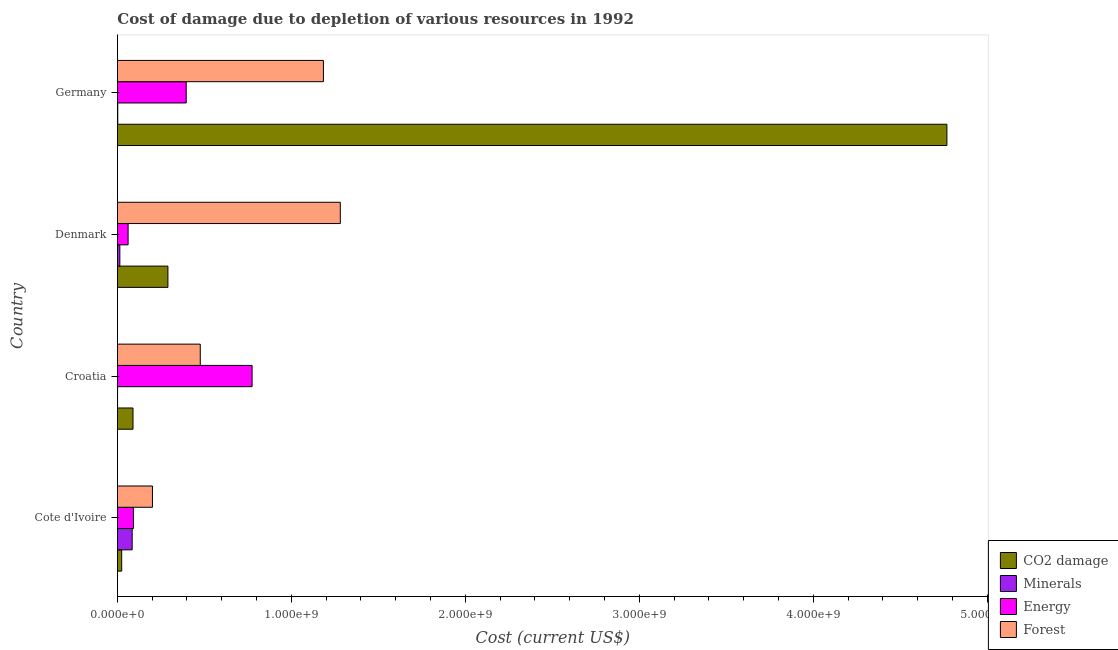How many different coloured bars are there?
Your answer should be compact. 4. How many bars are there on the 3rd tick from the top?
Your answer should be compact. 4. What is the label of the 1st group of bars from the top?
Make the answer very short. Germany. In how many cases, is the number of bars for a given country not equal to the number of legend labels?
Provide a succinct answer. 0. What is the cost of damage due to depletion of energy in Denmark?
Your answer should be compact. 6.16e+07. Across all countries, what is the maximum cost of damage due to depletion of coal?
Ensure brevity in your answer.  4.77e+09. Across all countries, what is the minimum cost of damage due to depletion of minerals?
Your answer should be very brief. 9.29e+05. In which country was the cost of damage due to depletion of minerals maximum?
Provide a succinct answer. Cote d'Ivoire. In which country was the cost of damage due to depletion of minerals minimum?
Your response must be concise. Croatia. What is the total cost of damage due to depletion of minerals in the graph?
Give a very brief answer. 1.02e+08. What is the difference between the cost of damage due to depletion of forests in Cote d'Ivoire and that in Germany?
Offer a very short reply. -9.83e+08. What is the difference between the cost of damage due to depletion of energy in Croatia and the cost of damage due to depletion of minerals in Germany?
Keep it short and to the point. 7.72e+08. What is the average cost of damage due to depletion of minerals per country?
Give a very brief answer. 2.55e+07. What is the difference between the cost of damage due to depletion of minerals and cost of damage due to depletion of energy in Croatia?
Your answer should be compact. -7.73e+08. In how many countries, is the cost of damage due to depletion of coal greater than 2600000000 US$?
Offer a terse response. 1. What is the ratio of the cost of damage due to depletion of coal in Cote d'Ivoire to that in Croatia?
Offer a very short reply. 0.28. Is the cost of damage due to depletion of coal in Croatia less than that in Germany?
Your response must be concise. Yes. What is the difference between the highest and the second highest cost of damage due to depletion of energy?
Provide a succinct answer. 3.79e+08. What is the difference between the highest and the lowest cost of damage due to depletion of energy?
Make the answer very short. 7.13e+08. In how many countries, is the cost of damage due to depletion of forests greater than the average cost of damage due to depletion of forests taken over all countries?
Provide a succinct answer. 2. Is the sum of the cost of damage due to depletion of energy in Denmark and Germany greater than the maximum cost of damage due to depletion of forests across all countries?
Your answer should be very brief. No. What does the 2nd bar from the top in Croatia represents?
Your response must be concise. Energy. What does the 4th bar from the bottom in Denmark represents?
Provide a succinct answer. Forest. Is it the case that in every country, the sum of the cost of damage due to depletion of coal and cost of damage due to depletion of minerals is greater than the cost of damage due to depletion of energy?
Keep it short and to the point. No. Are all the bars in the graph horizontal?
Keep it short and to the point. Yes. What is the difference between two consecutive major ticks on the X-axis?
Offer a terse response. 1.00e+09. Are the values on the major ticks of X-axis written in scientific E-notation?
Offer a very short reply. Yes. Does the graph contain any zero values?
Provide a short and direct response. No. Does the graph contain grids?
Offer a very short reply. No. How many legend labels are there?
Make the answer very short. 4. What is the title of the graph?
Your answer should be very brief. Cost of damage due to depletion of various resources in 1992 . What is the label or title of the X-axis?
Provide a short and direct response. Cost (current US$). What is the label or title of the Y-axis?
Provide a short and direct response. Country. What is the Cost (current US$) in CO2 damage in Cote d'Ivoire?
Make the answer very short. 2.47e+07. What is the Cost (current US$) of Minerals in Cote d'Ivoire?
Provide a succinct answer. 8.49e+07. What is the Cost (current US$) in Energy in Cote d'Ivoire?
Your answer should be very brief. 9.22e+07. What is the Cost (current US$) in Forest in Cote d'Ivoire?
Your answer should be very brief. 2.01e+08. What is the Cost (current US$) in CO2 damage in Croatia?
Provide a succinct answer. 8.97e+07. What is the Cost (current US$) in Minerals in Croatia?
Offer a very short reply. 9.29e+05. What is the Cost (current US$) of Energy in Croatia?
Provide a succinct answer. 7.74e+08. What is the Cost (current US$) of Forest in Croatia?
Your answer should be very brief. 4.76e+08. What is the Cost (current US$) of CO2 damage in Denmark?
Ensure brevity in your answer.  2.90e+08. What is the Cost (current US$) in Minerals in Denmark?
Ensure brevity in your answer.  1.40e+07. What is the Cost (current US$) of Energy in Denmark?
Keep it short and to the point. 6.16e+07. What is the Cost (current US$) of Forest in Denmark?
Give a very brief answer. 1.28e+09. What is the Cost (current US$) in CO2 damage in Germany?
Your answer should be compact. 4.77e+09. What is the Cost (current US$) of Minerals in Germany?
Your answer should be very brief. 2.06e+06. What is the Cost (current US$) in Energy in Germany?
Your response must be concise. 3.95e+08. What is the Cost (current US$) of Forest in Germany?
Provide a succinct answer. 1.18e+09. Across all countries, what is the maximum Cost (current US$) of CO2 damage?
Provide a short and direct response. 4.77e+09. Across all countries, what is the maximum Cost (current US$) of Minerals?
Offer a terse response. 8.49e+07. Across all countries, what is the maximum Cost (current US$) of Energy?
Keep it short and to the point. 7.74e+08. Across all countries, what is the maximum Cost (current US$) of Forest?
Make the answer very short. 1.28e+09. Across all countries, what is the minimum Cost (current US$) of CO2 damage?
Your answer should be very brief. 2.47e+07. Across all countries, what is the minimum Cost (current US$) in Minerals?
Your answer should be compact. 9.29e+05. Across all countries, what is the minimum Cost (current US$) in Energy?
Keep it short and to the point. 6.16e+07. Across all countries, what is the minimum Cost (current US$) in Forest?
Your answer should be compact. 2.01e+08. What is the total Cost (current US$) of CO2 damage in the graph?
Provide a succinct answer. 5.17e+09. What is the total Cost (current US$) in Minerals in the graph?
Give a very brief answer. 1.02e+08. What is the total Cost (current US$) of Energy in the graph?
Keep it short and to the point. 1.32e+09. What is the total Cost (current US$) in Forest in the graph?
Provide a succinct answer. 3.14e+09. What is the difference between the Cost (current US$) in CO2 damage in Cote d'Ivoire and that in Croatia?
Give a very brief answer. -6.49e+07. What is the difference between the Cost (current US$) in Minerals in Cote d'Ivoire and that in Croatia?
Make the answer very short. 8.40e+07. What is the difference between the Cost (current US$) of Energy in Cote d'Ivoire and that in Croatia?
Make the answer very short. -6.82e+08. What is the difference between the Cost (current US$) of Forest in Cote d'Ivoire and that in Croatia?
Keep it short and to the point. -2.75e+08. What is the difference between the Cost (current US$) of CO2 damage in Cote d'Ivoire and that in Denmark?
Ensure brevity in your answer.  -2.66e+08. What is the difference between the Cost (current US$) of Minerals in Cote d'Ivoire and that in Denmark?
Offer a terse response. 7.09e+07. What is the difference between the Cost (current US$) in Energy in Cote d'Ivoire and that in Denmark?
Give a very brief answer. 3.06e+07. What is the difference between the Cost (current US$) of Forest in Cote d'Ivoire and that in Denmark?
Ensure brevity in your answer.  -1.08e+09. What is the difference between the Cost (current US$) in CO2 damage in Cote d'Ivoire and that in Germany?
Your response must be concise. -4.74e+09. What is the difference between the Cost (current US$) of Minerals in Cote d'Ivoire and that in Germany?
Your answer should be compact. 8.28e+07. What is the difference between the Cost (current US$) in Energy in Cote d'Ivoire and that in Germany?
Ensure brevity in your answer.  -3.03e+08. What is the difference between the Cost (current US$) in Forest in Cote d'Ivoire and that in Germany?
Provide a short and direct response. -9.83e+08. What is the difference between the Cost (current US$) in CO2 damage in Croatia and that in Denmark?
Your answer should be very brief. -2.01e+08. What is the difference between the Cost (current US$) in Minerals in Croatia and that in Denmark?
Offer a terse response. -1.31e+07. What is the difference between the Cost (current US$) in Energy in Croatia and that in Denmark?
Give a very brief answer. 7.13e+08. What is the difference between the Cost (current US$) of Forest in Croatia and that in Denmark?
Provide a short and direct response. -8.05e+08. What is the difference between the Cost (current US$) of CO2 damage in Croatia and that in Germany?
Keep it short and to the point. -4.68e+09. What is the difference between the Cost (current US$) in Minerals in Croatia and that in Germany?
Offer a very short reply. -1.14e+06. What is the difference between the Cost (current US$) in Energy in Croatia and that in Germany?
Ensure brevity in your answer.  3.79e+08. What is the difference between the Cost (current US$) of Forest in Croatia and that in Germany?
Ensure brevity in your answer.  -7.08e+08. What is the difference between the Cost (current US$) of CO2 damage in Denmark and that in Germany?
Make the answer very short. -4.48e+09. What is the difference between the Cost (current US$) in Minerals in Denmark and that in Germany?
Provide a succinct answer. 1.20e+07. What is the difference between the Cost (current US$) of Energy in Denmark and that in Germany?
Offer a terse response. -3.34e+08. What is the difference between the Cost (current US$) of Forest in Denmark and that in Germany?
Provide a short and direct response. 9.71e+07. What is the difference between the Cost (current US$) of CO2 damage in Cote d'Ivoire and the Cost (current US$) of Minerals in Croatia?
Offer a very short reply. 2.38e+07. What is the difference between the Cost (current US$) in CO2 damage in Cote d'Ivoire and the Cost (current US$) in Energy in Croatia?
Offer a very short reply. -7.50e+08. What is the difference between the Cost (current US$) in CO2 damage in Cote d'Ivoire and the Cost (current US$) in Forest in Croatia?
Provide a succinct answer. -4.52e+08. What is the difference between the Cost (current US$) in Minerals in Cote d'Ivoire and the Cost (current US$) in Energy in Croatia?
Keep it short and to the point. -6.89e+08. What is the difference between the Cost (current US$) of Minerals in Cote d'Ivoire and the Cost (current US$) of Forest in Croatia?
Offer a very short reply. -3.91e+08. What is the difference between the Cost (current US$) in Energy in Cote d'Ivoire and the Cost (current US$) in Forest in Croatia?
Provide a succinct answer. -3.84e+08. What is the difference between the Cost (current US$) of CO2 damage in Cote d'Ivoire and the Cost (current US$) of Minerals in Denmark?
Keep it short and to the point. 1.07e+07. What is the difference between the Cost (current US$) in CO2 damage in Cote d'Ivoire and the Cost (current US$) in Energy in Denmark?
Provide a short and direct response. -3.69e+07. What is the difference between the Cost (current US$) of CO2 damage in Cote d'Ivoire and the Cost (current US$) of Forest in Denmark?
Your answer should be compact. -1.26e+09. What is the difference between the Cost (current US$) in Minerals in Cote d'Ivoire and the Cost (current US$) in Energy in Denmark?
Ensure brevity in your answer.  2.33e+07. What is the difference between the Cost (current US$) of Minerals in Cote d'Ivoire and the Cost (current US$) of Forest in Denmark?
Your response must be concise. -1.20e+09. What is the difference between the Cost (current US$) of Energy in Cote d'Ivoire and the Cost (current US$) of Forest in Denmark?
Provide a succinct answer. -1.19e+09. What is the difference between the Cost (current US$) in CO2 damage in Cote d'Ivoire and the Cost (current US$) in Minerals in Germany?
Offer a very short reply. 2.27e+07. What is the difference between the Cost (current US$) of CO2 damage in Cote d'Ivoire and the Cost (current US$) of Energy in Germany?
Offer a terse response. -3.71e+08. What is the difference between the Cost (current US$) in CO2 damage in Cote d'Ivoire and the Cost (current US$) in Forest in Germany?
Provide a short and direct response. -1.16e+09. What is the difference between the Cost (current US$) of Minerals in Cote d'Ivoire and the Cost (current US$) of Energy in Germany?
Offer a very short reply. -3.11e+08. What is the difference between the Cost (current US$) of Minerals in Cote d'Ivoire and the Cost (current US$) of Forest in Germany?
Ensure brevity in your answer.  -1.10e+09. What is the difference between the Cost (current US$) in Energy in Cote d'Ivoire and the Cost (current US$) in Forest in Germany?
Keep it short and to the point. -1.09e+09. What is the difference between the Cost (current US$) of CO2 damage in Croatia and the Cost (current US$) of Minerals in Denmark?
Make the answer very short. 7.56e+07. What is the difference between the Cost (current US$) in CO2 damage in Croatia and the Cost (current US$) in Energy in Denmark?
Your answer should be very brief. 2.81e+07. What is the difference between the Cost (current US$) of CO2 damage in Croatia and the Cost (current US$) of Forest in Denmark?
Provide a short and direct response. -1.19e+09. What is the difference between the Cost (current US$) of Minerals in Croatia and the Cost (current US$) of Energy in Denmark?
Make the answer very short. -6.07e+07. What is the difference between the Cost (current US$) in Minerals in Croatia and the Cost (current US$) in Forest in Denmark?
Keep it short and to the point. -1.28e+09. What is the difference between the Cost (current US$) of Energy in Croatia and the Cost (current US$) of Forest in Denmark?
Provide a short and direct response. -5.07e+08. What is the difference between the Cost (current US$) of CO2 damage in Croatia and the Cost (current US$) of Minerals in Germany?
Keep it short and to the point. 8.76e+07. What is the difference between the Cost (current US$) of CO2 damage in Croatia and the Cost (current US$) of Energy in Germany?
Your response must be concise. -3.06e+08. What is the difference between the Cost (current US$) of CO2 damage in Croatia and the Cost (current US$) of Forest in Germany?
Your answer should be very brief. -1.09e+09. What is the difference between the Cost (current US$) in Minerals in Croatia and the Cost (current US$) in Energy in Germany?
Offer a very short reply. -3.95e+08. What is the difference between the Cost (current US$) of Minerals in Croatia and the Cost (current US$) of Forest in Germany?
Offer a very short reply. -1.18e+09. What is the difference between the Cost (current US$) in Energy in Croatia and the Cost (current US$) in Forest in Germany?
Provide a succinct answer. -4.10e+08. What is the difference between the Cost (current US$) in CO2 damage in Denmark and the Cost (current US$) in Minerals in Germany?
Offer a very short reply. 2.88e+08. What is the difference between the Cost (current US$) in CO2 damage in Denmark and the Cost (current US$) in Energy in Germany?
Offer a very short reply. -1.05e+08. What is the difference between the Cost (current US$) of CO2 damage in Denmark and the Cost (current US$) of Forest in Germany?
Your response must be concise. -8.94e+08. What is the difference between the Cost (current US$) of Minerals in Denmark and the Cost (current US$) of Energy in Germany?
Give a very brief answer. -3.81e+08. What is the difference between the Cost (current US$) in Minerals in Denmark and the Cost (current US$) in Forest in Germany?
Provide a short and direct response. -1.17e+09. What is the difference between the Cost (current US$) in Energy in Denmark and the Cost (current US$) in Forest in Germany?
Your answer should be very brief. -1.12e+09. What is the average Cost (current US$) in CO2 damage per country?
Offer a terse response. 1.29e+09. What is the average Cost (current US$) of Minerals per country?
Your response must be concise. 2.55e+07. What is the average Cost (current US$) of Energy per country?
Offer a terse response. 3.31e+08. What is the average Cost (current US$) of Forest per country?
Your answer should be very brief. 7.86e+08. What is the difference between the Cost (current US$) of CO2 damage and Cost (current US$) of Minerals in Cote d'Ivoire?
Keep it short and to the point. -6.02e+07. What is the difference between the Cost (current US$) of CO2 damage and Cost (current US$) of Energy in Cote d'Ivoire?
Provide a succinct answer. -6.75e+07. What is the difference between the Cost (current US$) in CO2 damage and Cost (current US$) in Forest in Cote d'Ivoire?
Make the answer very short. -1.77e+08. What is the difference between the Cost (current US$) in Minerals and Cost (current US$) in Energy in Cote d'Ivoire?
Provide a succinct answer. -7.29e+06. What is the difference between the Cost (current US$) of Minerals and Cost (current US$) of Forest in Cote d'Ivoire?
Offer a very short reply. -1.17e+08. What is the difference between the Cost (current US$) of Energy and Cost (current US$) of Forest in Cote d'Ivoire?
Make the answer very short. -1.09e+08. What is the difference between the Cost (current US$) in CO2 damage and Cost (current US$) in Minerals in Croatia?
Provide a short and direct response. 8.87e+07. What is the difference between the Cost (current US$) in CO2 damage and Cost (current US$) in Energy in Croatia?
Make the answer very short. -6.85e+08. What is the difference between the Cost (current US$) in CO2 damage and Cost (current US$) in Forest in Croatia?
Make the answer very short. -3.87e+08. What is the difference between the Cost (current US$) in Minerals and Cost (current US$) in Energy in Croatia?
Give a very brief answer. -7.73e+08. What is the difference between the Cost (current US$) in Minerals and Cost (current US$) in Forest in Croatia?
Your response must be concise. -4.75e+08. What is the difference between the Cost (current US$) of Energy and Cost (current US$) of Forest in Croatia?
Offer a terse response. 2.98e+08. What is the difference between the Cost (current US$) of CO2 damage and Cost (current US$) of Minerals in Denmark?
Offer a terse response. 2.76e+08. What is the difference between the Cost (current US$) in CO2 damage and Cost (current US$) in Energy in Denmark?
Offer a terse response. 2.29e+08. What is the difference between the Cost (current US$) in CO2 damage and Cost (current US$) in Forest in Denmark?
Provide a succinct answer. -9.91e+08. What is the difference between the Cost (current US$) in Minerals and Cost (current US$) in Energy in Denmark?
Your answer should be compact. -4.76e+07. What is the difference between the Cost (current US$) of Minerals and Cost (current US$) of Forest in Denmark?
Offer a terse response. -1.27e+09. What is the difference between the Cost (current US$) in Energy and Cost (current US$) in Forest in Denmark?
Offer a terse response. -1.22e+09. What is the difference between the Cost (current US$) of CO2 damage and Cost (current US$) of Minerals in Germany?
Make the answer very short. 4.77e+09. What is the difference between the Cost (current US$) in CO2 damage and Cost (current US$) in Energy in Germany?
Ensure brevity in your answer.  4.37e+09. What is the difference between the Cost (current US$) in CO2 damage and Cost (current US$) in Forest in Germany?
Provide a short and direct response. 3.58e+09. What is the difference between the Cost (current US$) of Minerals and Cost (current US$) of Energy in Germany?
Give a very brief answer. -3.93e+08. What is the difference between the Cost (current US$) in Minerals and Cost (current US$) in Forest in Germany?
Provide a succinct answer. -1.18e+09. What is the difference between the Cost (current US$) in Energy and Cost (current US$) in Forest in Germany?
Offer a very short reply. -7.89e+08. What is the ratio of the Cost (current US$) in CO2 damage in Cote d'Ivoire to that in Croatia?
Your response must be concise. 0.28. What is the ratio of the Cost (current US$) in Minerals in Cote d'Ivoire to that in Croatia?
Make the answer very short. 91.43. What is the ratio of the Cost (current US$) in Energy in Cote d'Ivoire to that in Croatia?
Provide a short and direct response. 0.12. What is the ratio of the Cost (current US$) in Forest in Cote d'Ivoire to that in Croatia?
Offer a terse response. 0.42. What is the ratio of the Cost (current US$) of CO2 damage in Cote d'Ivoire to that in Denmark?
Ensure brevity in your answer.  0.09. What is the ratio of the Cost (current US$) in Minerals in Cote d'Ivoire to that in Denmark?
Give a very brief answer. 6.05. What is the ratio of the Cost (current US$) in Energy in Cote d'Ivoire to that in Denmark?
Provide a short and direct response. 1.5. What is the ratio of the Cost (current US$) in Forest in Cote d'Ivoire to that in Denmark?
Provide a succinct answer. 0.16. What is the ratio of the Cost (current US$) in CO2 damage in Cote d'Ivoire to that in Germany?
Provide a succinct answer. 0.01. What is the ratio of the Cost (current US$) of Minerals in Cote d'Ivoire to that in Germany?
Provide a short and direct response. 41.12. What is the ratio of the Cost (current US$) in Energy in Cote d'Ivoire to that in Germany?
Your answer should be compact. 0.23. What is the ratio of the Cost (current US$) in Forest in Cote d'Ivoire to that in Germany?
Give a very brief answer. 0.17. What is the ratio of the Cost (current US$) in CO2 damage in Croatia to that in Denmark?
Provide a short and direct response. 0.31. What is the ratio of the Cost (current US$) of Minerals in Croatia to that in Denmark?
Give a very brief answer. 0.07. What is the ratio of the Cost (current US$) of Energy in Croatia to that in Denmark?
Your answer should be very brief. 12.57. What is the ratio of the Cost (current US$) in Forest in Croatia to that in Denmark?
Offer a very short reply. 0.37. What is the ratio of the Cost (current US$) of CO2 damage in Croatia to that in Germany?
Offer a terse response. 0.02. What is the ratio of the Cost (current US$) of Minerals in Croatia to that in Germany?
Give a very brief answer. 0.45. What is the ratio of the Cost (current US$) in Energy in Croatia to that in Germany?
Give a very brief answer. 1.96. What is the ratio of the Cost (current US$) in Forest in Croatia to that in Germany?
Ensure brevity in your answer.  0.4. What is the ratio of the Cost (current US$) in CO2 damage in Denmark to that in Germany?
Make the answer very short. 0.06. What is the ratio of the Cost (current US$) in Minerals in Denmark to that in Germany?
Provide a succinct answer. 6.79. What is the ratio of the Cost (current US$) of Energy in Denmark to that in Germany?
Provide a succinct answer. 0.16. What is the ratio of the Cost (current US$) in Forest in Denmark to that in Germany?
Give a very brief answer. 1.08. What is the difference between the highest and the second highest Cost (current US$) of CO2 damage?
Ensure brevity in your answer.  4.48e+09. What is the difference between the highest and the second highest Cost (current US$) of Minerals?
Your response must be concise. 7.09e+07. What is the difference between the highest and the second highest Cost (current US$) in Energy?
Make the answer very short. 3.79e+08. What is the difference between the highest and the second highest Cost (current US$) in Forest?
Ensure brevity in your answer.  9.71e+07. What is the difference between the highest and the lowest Cost (current US$) of CO2 damage?
Ensure brevity in your answer.  4.74e+09. What is the difference between the highest and the lowest Cost (current US$) in Minerals?
Your answer should be compact. 8.40e+07. What is the difference between the highest and the lowest Cost (current US$) in Energy?
Your answer should be compact. 7.13e+08. What is the difference between the highest and the lowest Cost (current US$) in Forest?
Your response must be concise. 1.08e+09. 